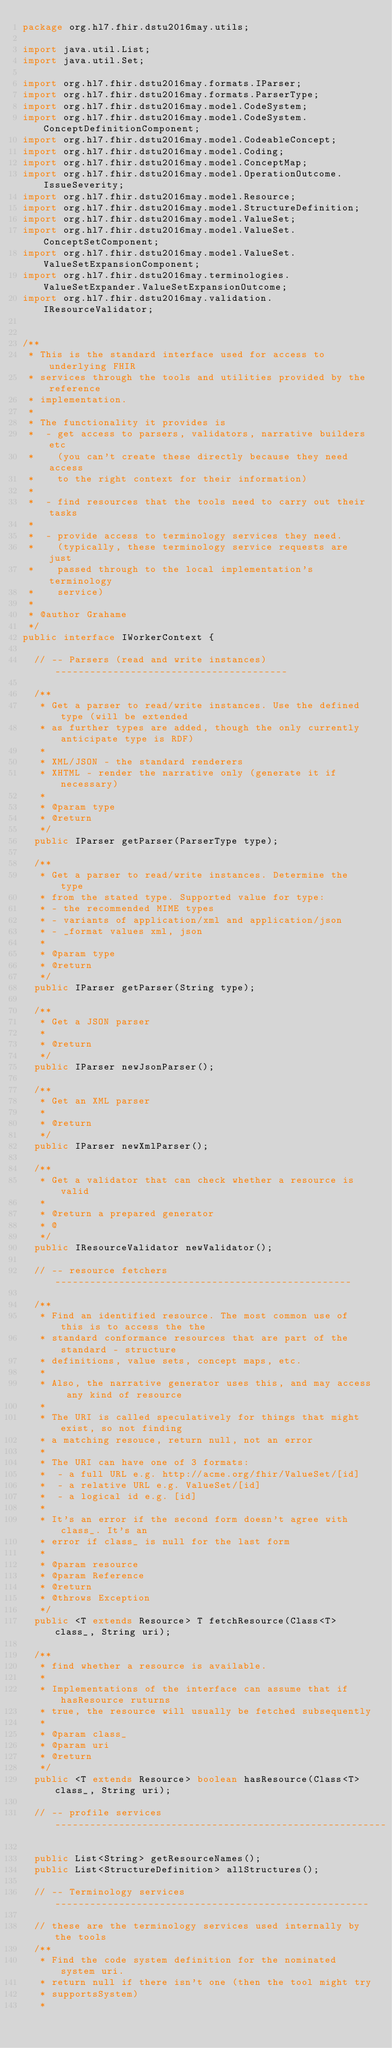Convert code to text. <code><loc_0><loc_0><loc_500><loc_500><_Java_>package org.hl7.fhir.dstu2016may.utils;

import java.util.List;
import java.util.Set;

import org.hl7.fhir.dstu2016may.formats.IParser;
import org.hl7.fhir.dstu2016may.formats.ParserType;
import org.hl7.fhir.dstu2016may.model.CodeSystem;
import org.hl7.fhir.dstu2016may.model.CodeSystem.ConceptDefinitionComponent;
import org.hl7.fhir.dstu2016may.model.CodeableConcept;
import org.hl7.fhir.dstu2016may.model.Coding;
import org.hl7.fhir.dstu2016may.model.ConceptMap;
import org.hl7.fhir.dstu2016may.model.OperationOutcome.IssueSeverity;
import org.hl7.fhir.dstu2016may.model.Resource;
import org.hl7.fhir.dstu2016may.model.StructureDefinition;
import org.hl7.fhir.dstu2016may.model.ValueSet;
import org.hl7.fhir.dstu2016may.model.ValueSet.ConceptSetComponent;
import org.hl7.fhir.dstu2016may.model.ValueSet.ValueSetExpansionComponent;
import org.hl7.fhir.dstu2016may.terminologies.ValueSetExpander.ValueSetExpansionOutcome;
import org.hl7.fhir.dstu2016may.validation.IResourceValidator;


/**
 * This is the standard interface used for access to underlying FHIR
 * services through the tools and utilities provided by the reference
 * implementation. 
 * 
 * The functionality it provides is 
 *  - get access to parsers, validators, narrative builders etc
 *    (you can't create these directly because they need access 
 *    to the right context for their information)
 *    
 *  - find resources that the tools need to carry out their tasks
 *  
 *  - provide access to terminology services they need. 
 *    (typically, these terminology service requests are just
 *    passed through to the local implementation's terminology
 *    service)    
 *  
 * @author Grahame
 */
public interface IWorkerContext {

  // -- Parsers (read and write instances) ----------------------------------------

  /**
   * Get a parser to read/write instances. Use the defined type (will be extended 
   * as further types are added, though the only currently anticipate type is RDF)
   * 
   * XML/JSON - the standard renderers
   * XHTML - render the narrative only (generate it if necessary)
   * 
   * @param type
   * @return
   */
  public IParser getParser(ParserType type);

  /**
   * Get a parser to read/write instances. Determine the type 
   * from the stated type. Supported value for type:
   * - the recommended MIME types
   * - variants of application/xml and application/json
   * - _format values xml, json
   * 
   * @param type
   * @return
   */	
  public IParser getParser(String type);

  /**
   * Get a JSON parser
   * 
   * @return
   */
  public IParser newJsonParser();

  /**
   * Get an XML parser
   * 
   * @return
   */
  public IParser newXmlParser();

  /**
   * Get a validator that can check whether a resource is valid 
   * 
   * @return a prepared generator
   * @
   */
  public IResourceValidator newValidator();

  // -- resource fetchers ---------------------------------------------------

  /**
   * Find an identified resource. The most common use of this is to access the the 
   * standard conformance resources that are part of the standard - structure 
   * definitions, value sets, concept maps, etc.
   * 
   * Also, the narrative generator uses this, and may access any kind of resource
   * 
   * The URI is called speculatively for things that might exist, so not finding 
   * a matching resouce, return null, not an error
   * 
   * The URI can have one of 3 formats:
   *  - a full URL e.g. http://acme.org/fhir/ValueSet/[id]
   *  - a relative URL e.g. ValueSet/[id]
   *  - a logical id e.g. [id]
   *  
   * It's an error if the second form doesn't agree with class_. It's an 
   * error if class_ is null for the last form
   * 
   * @param resource
   * @param Reference
   * @return
   * @throws Exception
   */
  public <T extends Resource> T fetchResource(Class<T> class_, String uri);

  /**
   * find whether a resource is available. 
   * 
   * Implementations of the interface can assume that if hasResource ruturns 
   * true, the resource will usually be fetched subsequently
   * 
   * @param class_
   * @param uri
   * @return
   */
  public <T extends Resource> boolean hasResource(Class<T> class_, String uri);

  // -- profile services ---------------------------------------------------------
  
  public List<String> getResourceNames();
  public List<StructureDefinition> allStructures();
  
  // -- Terminology services ------------------------------------------------------

  // these are the terminology services used internally by the tools
  /**
   * Find the code system definition for the nominated system uri. 
   * return null if there isn't one (then the tool might try 
   * supportsSystem)
   * </code> 